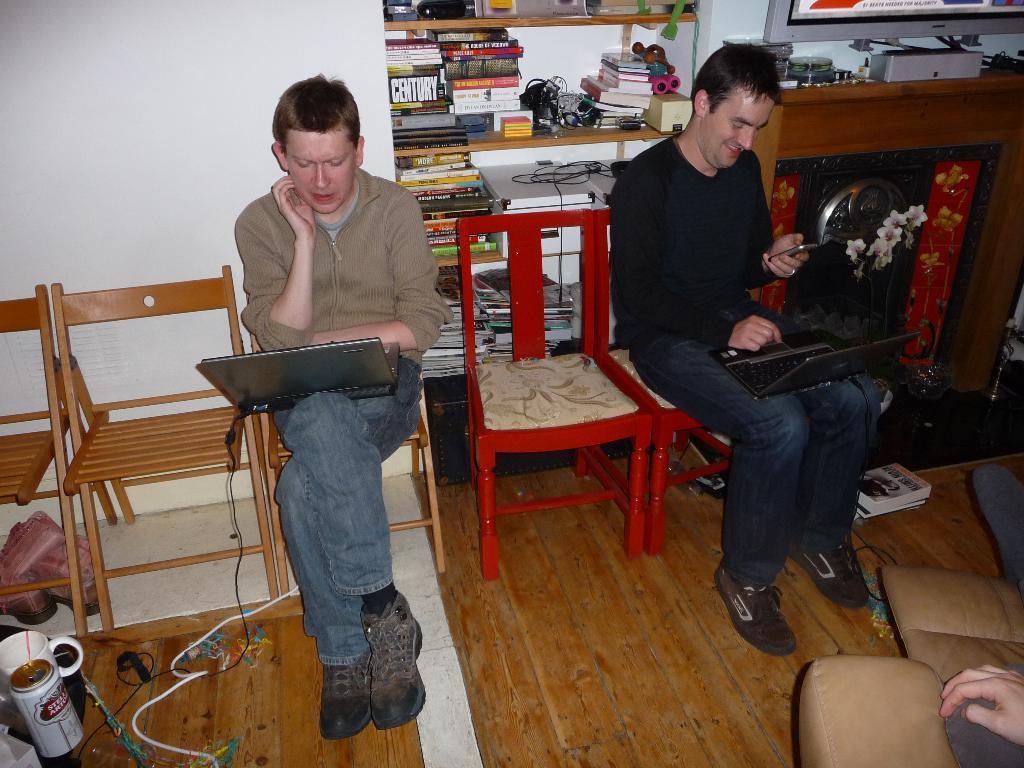Could you give a brief overview of what you see in this image? In the image there are two boys who are sitting on chair and using the laptop, at the back side there is a shelf in which there are books,wires and toys. On the floor there is a cup,wire,books. 